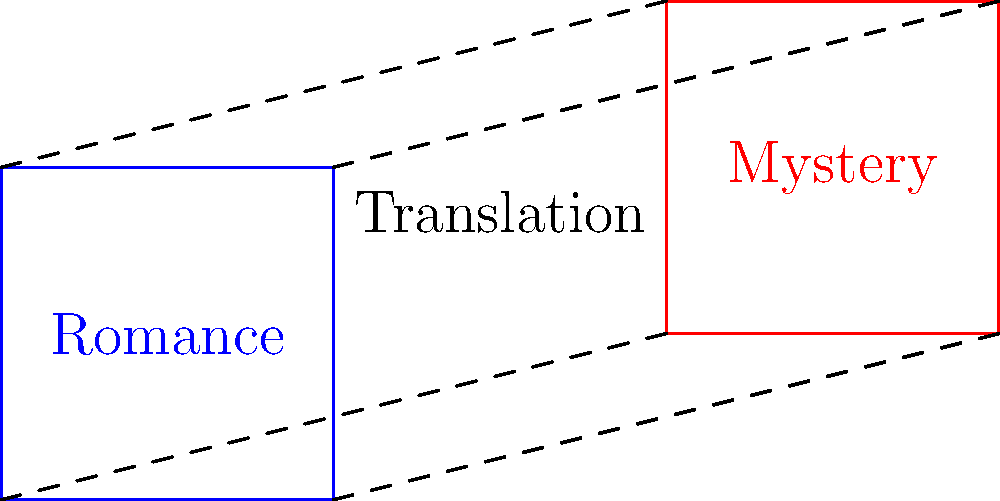In the context of transforming a story from the romance genre to the mystery genre, which geometric transformation best represents the translation of story elements, and how does this relate to maintaining narrative flow and clarity? To answer this question, let's analyze the geometric transformation shown in the diagram and relate it to narrative transformation:

1. Observe the blue square labeled "Romance" and the red parallelogram labeled "Mystery."

2. Notice the dashed lines connecting corresponding vertices of the two shapes.

3. The transformation shown is a translation combined with a shear:
   - The shape moves to a new position (translation)
   - The angles and proportions change (shear)

4. In storytelling terms:
   - Translation represents moving core story elements from one genre to another
   - Shear represents adapting these elements to fit the new genre's conventions

5. Narrative flow and clarity are maintained by:
   - Preserving the basic structure (four sides/key plot points)
   - Adjusting the details (angles/specific genre elements) to fit the new context

6. This transformation allows for:
   - Retention of fundamental story elements (characters, themes, conflicts)
   - Adaptation of tone, pacing, and style to suit the mystery genre

7. The geometric transformation thus illustrates how an author can successfully translate a romance story into a mystery while maintaining narrative integrity.
Answer: Translation with shear, preserving core elements while adapting to new genre conventions. 